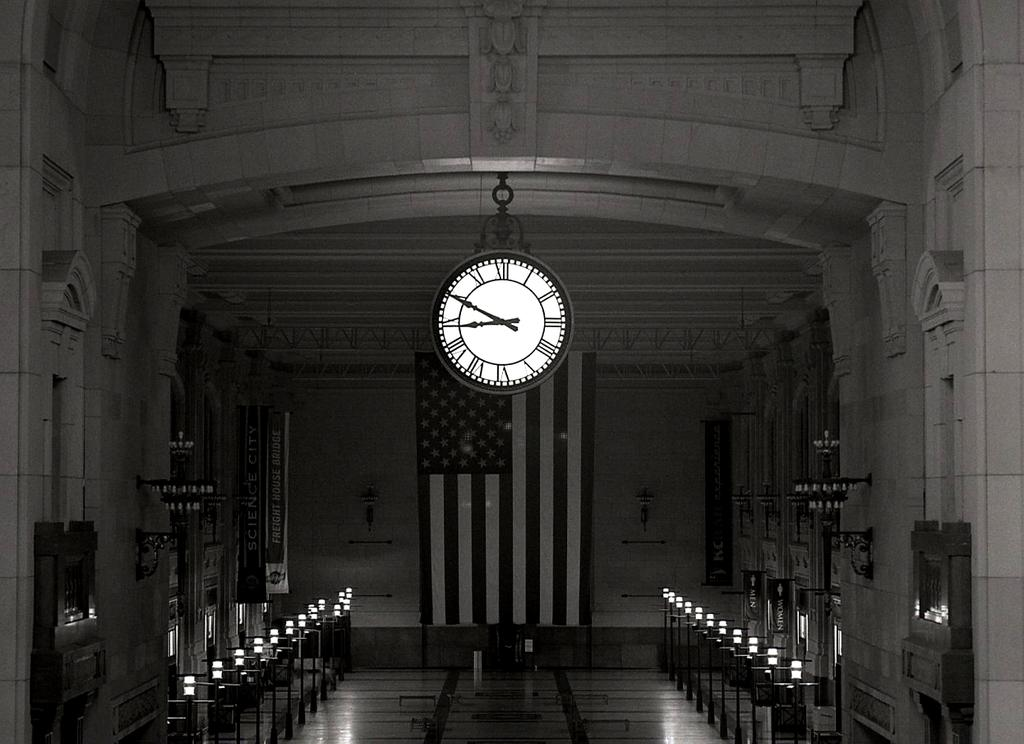<image>
Describe the image concisely. American flag under a clock with the hands on the numbers 9 and 10. 